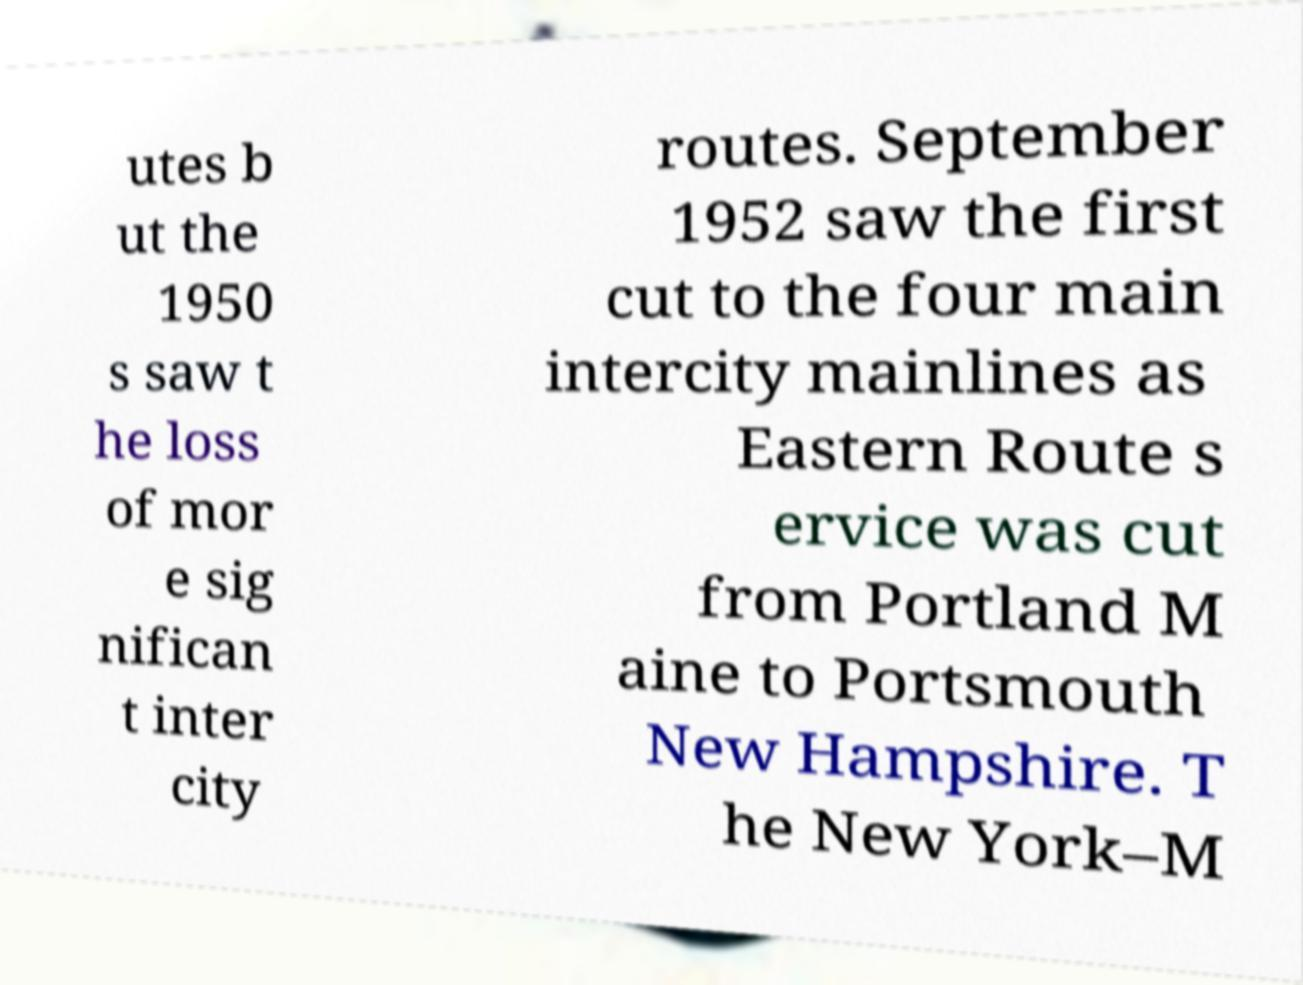For documentation purposes, I need the text within this image transcribed. Could you provide that? utes b ut the 1950 s saw t he loss of mor e sig nifican t inter city routes. September 1952 saw the first cut to the four main intercity mainlines as Eastern Route s ervice was cut from Portland M aine to Portsmouth New Hampshire. T he New York–M 